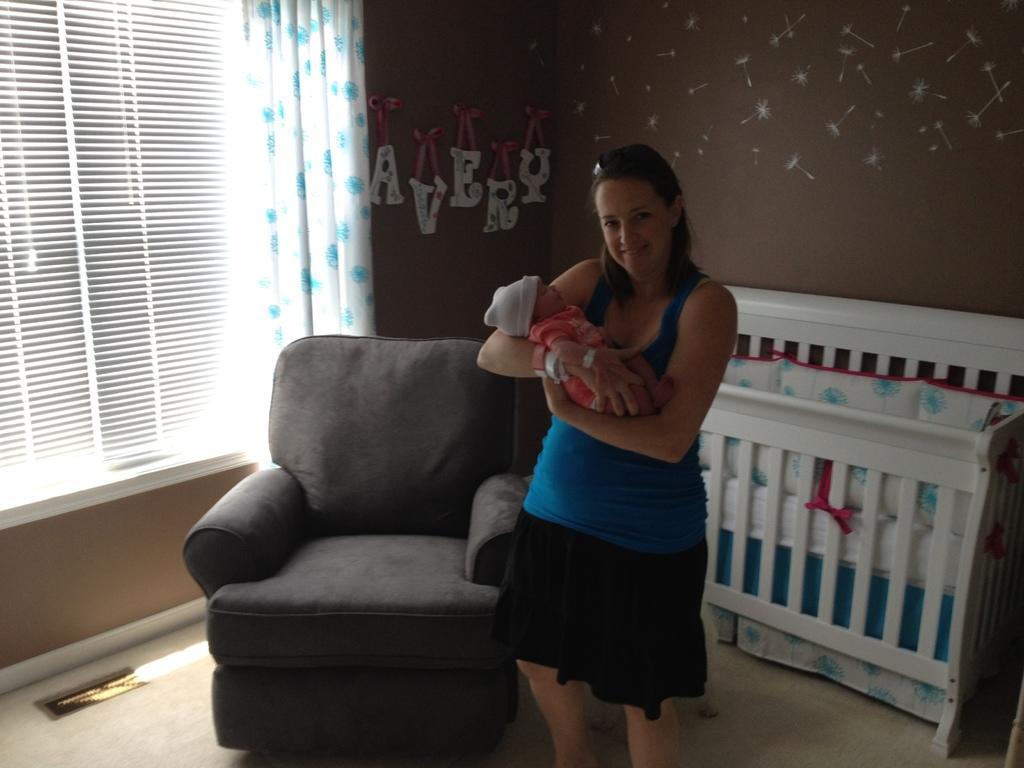Describe this image in one or two sentences. In this picture we can see a woman, she is holding a baby in her hands, beside to her we can see a sofa and a cradle, in the background we can see curtains and window blinds. 